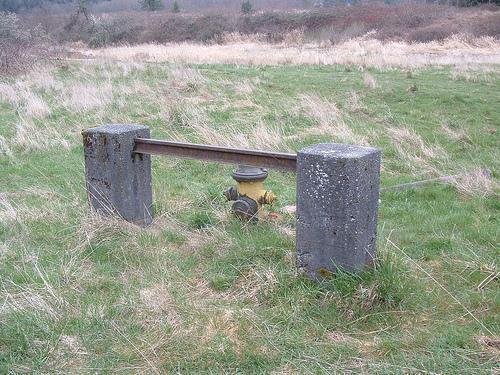How many cement pillars are holding up the bench?
Give a very brief answer. 2. 